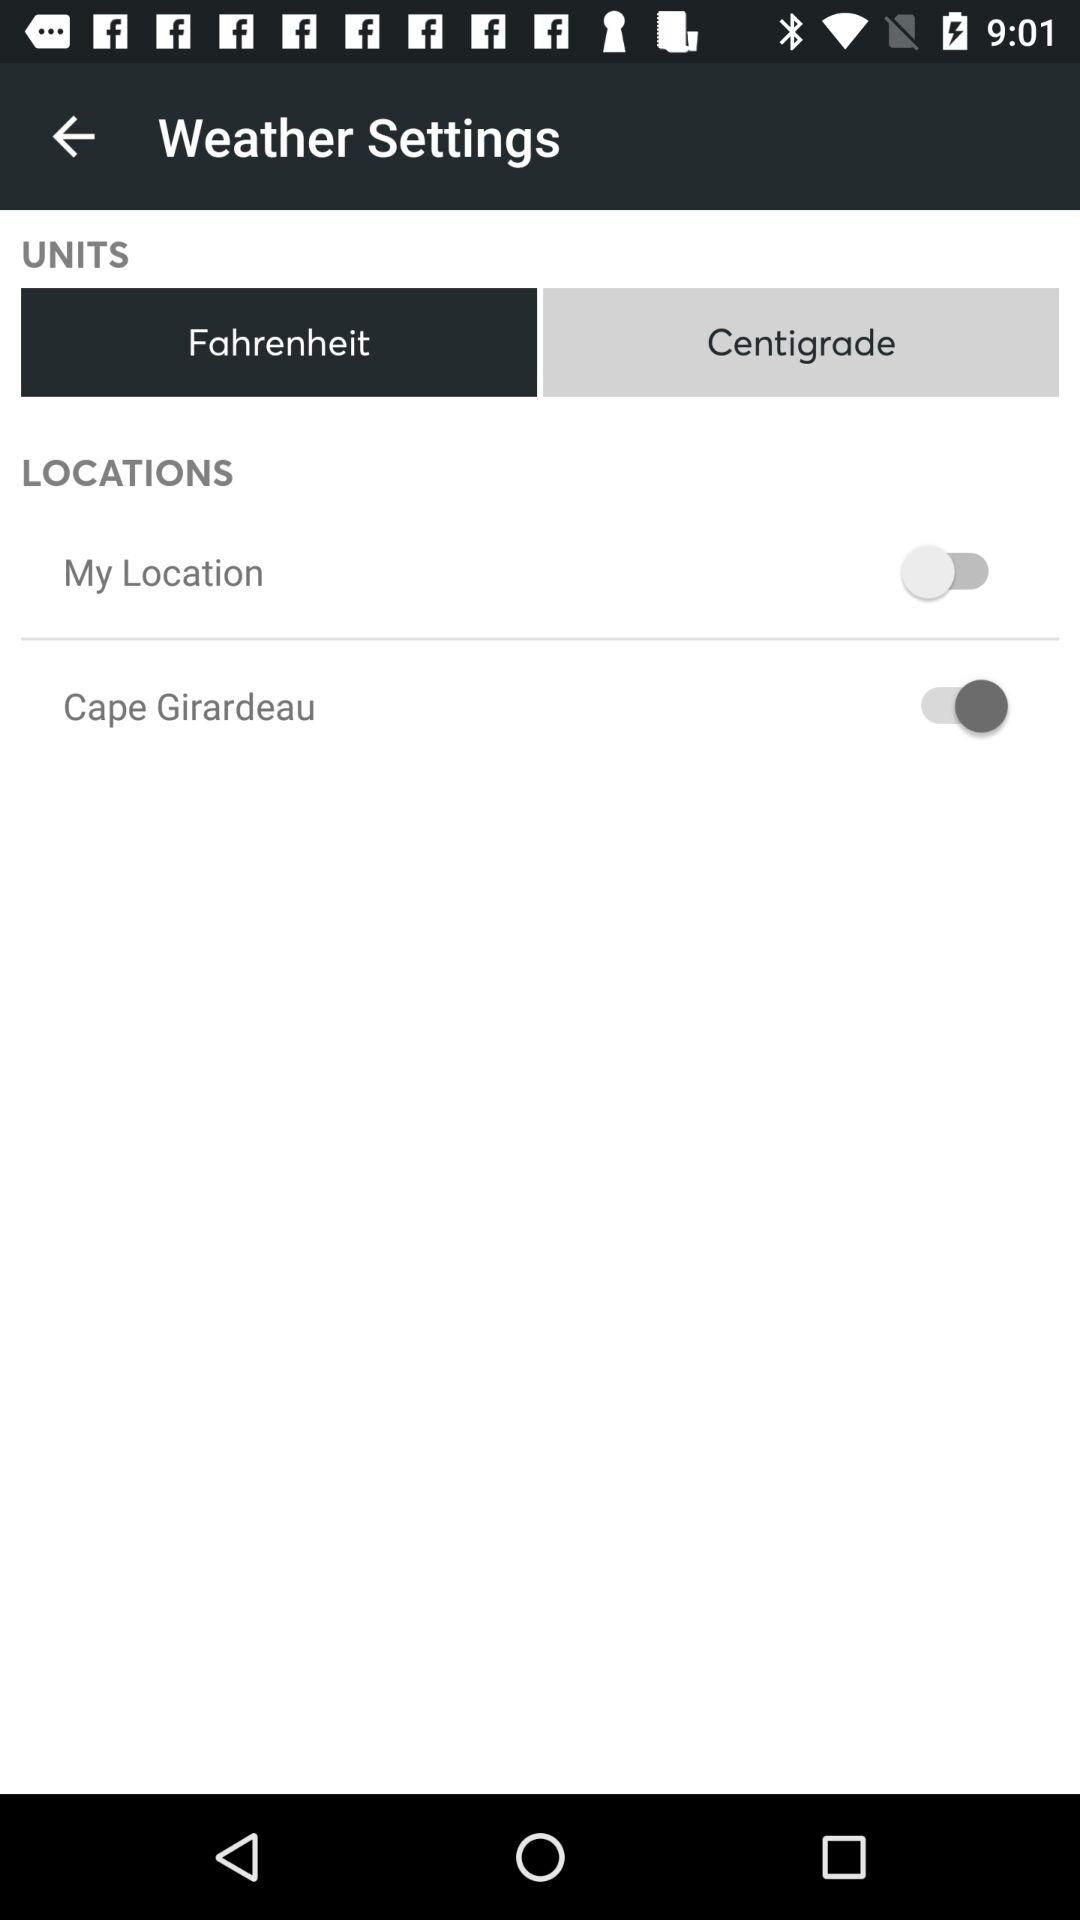What is the status of the "Cape Girardeau"? The status is "on". 